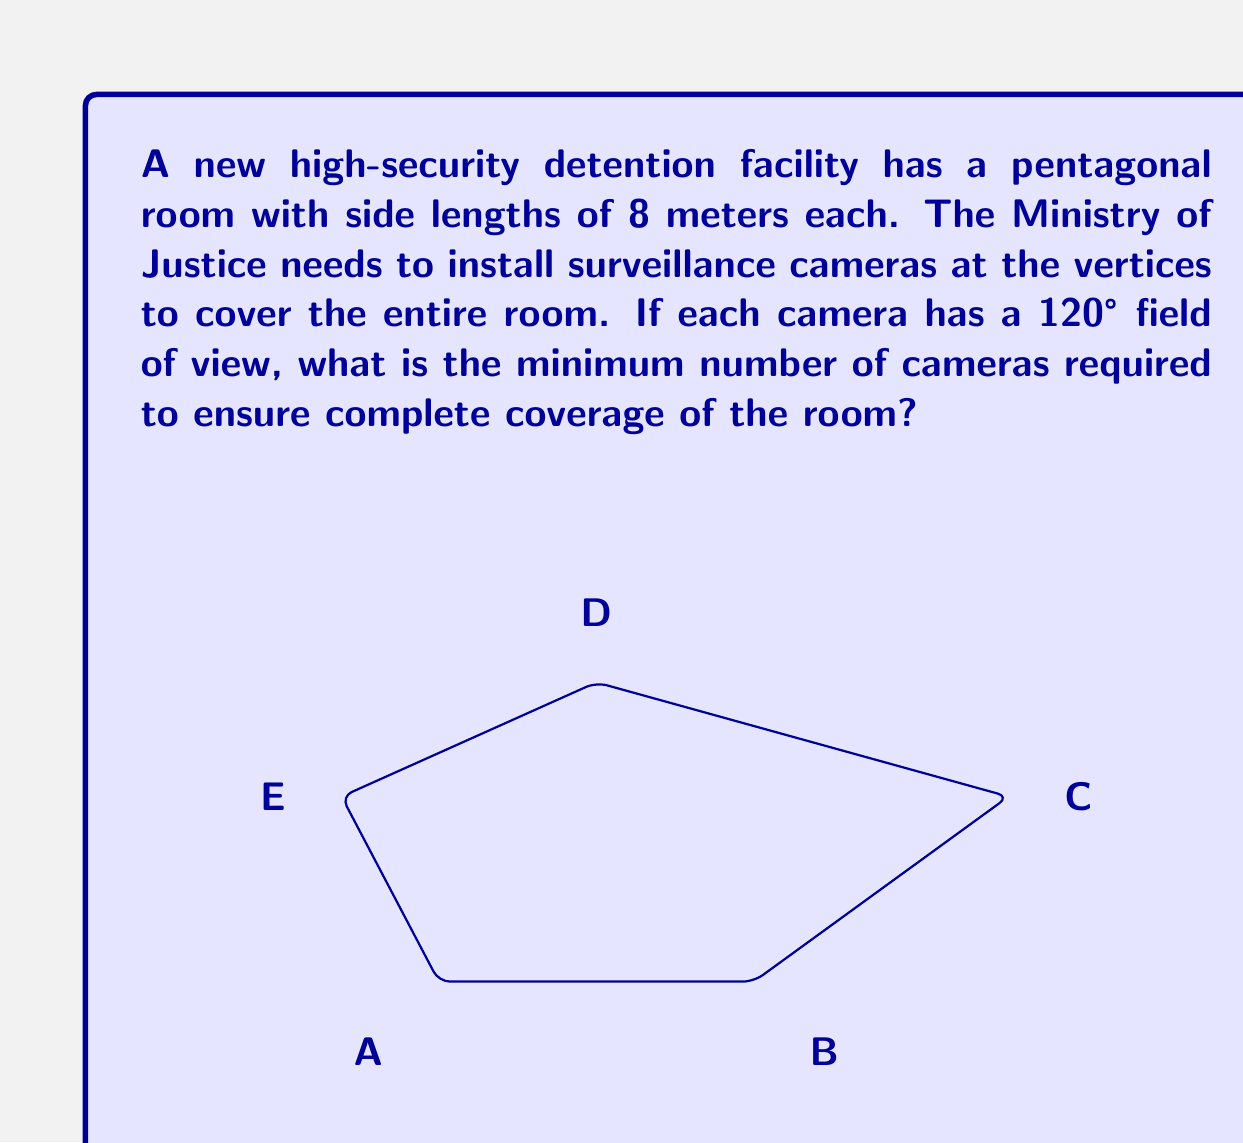Can you answer this question? To solve this problem, we need to follow these steps:

1) First, recall that the sum of interior angles of a pentagon is given by the formula:
   $$(n-2) \times 180°$$
   where n is the number of sides. For a pentagon, n = 5.

2) Calculate the sum of interior angles:
   $$(5-2) \times 180° = 3 \times 180° = 540°$$

3) Since the pentagon is regular (all sides are equal), each interior angle measures:
   $$\frac{540°}{5} = 108°$$

4) The exterior angle at each vertex is supplementary to the interior angle:
   $$180° - 108° = 72°$$

5) Each camera has a 120° field of view. To cover the exterior angle and some additional space, we need:
   $$\frac{72°}{120°} \approx 0.6$$ cameras per vertex

6) For complete coverage, we need to round up to the nearest whole number:
   $$\lceil 0.6 \times 5 \rceil = \lceil 3 \rceil = 3$$ cameras

Therefore, a minimum of 3 cameras is required to ensure complete coverage of the pentagonal room.
Answer: 3 cameras 